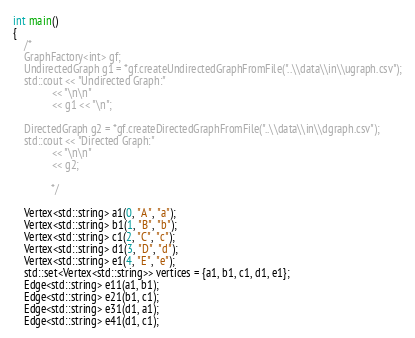Convert code to text. <code><loc_0><loc_0><loc_500><loc_500><_C++_>int main()
{
    /*
    GraphFactory<int> gf;
    UndirectedGraph g1 = *gf.createUndirectedGraphFromFile("..\\data\\in\\ugraph.csv");
    std::cout << "Undirected Graph:"
              << "\n\n"
              << g1 << "\n";

    DirectedGraph g2 = *gf.createDirectedGraphFromFile("..\\data\\in\\dgraph.csv");
    std::cout << "Directed Graph:"
              << "\n\n"
              << g2;

              */

    Vertex<std::string> a1(0, "A", "a");
    Vertex<std::string> b1(1, "B", "b");
    Vertex<std::string> c1(2, "C", "c");
    Vertex<std::string> d1(3, "D", "d");
    Vertex<std::string> e1(4, "E", "e");
    std::set<Vertex<std::string>> vertices = {a1, b1, c1, d1, e1};
    Edge<std::string> e11(a1, b1);
    Edge<std::string> e21(b1, c1);
    Edge<std::string> e31(d1, a1);
    Edge<std::string> e41(d1, c1);</code> 